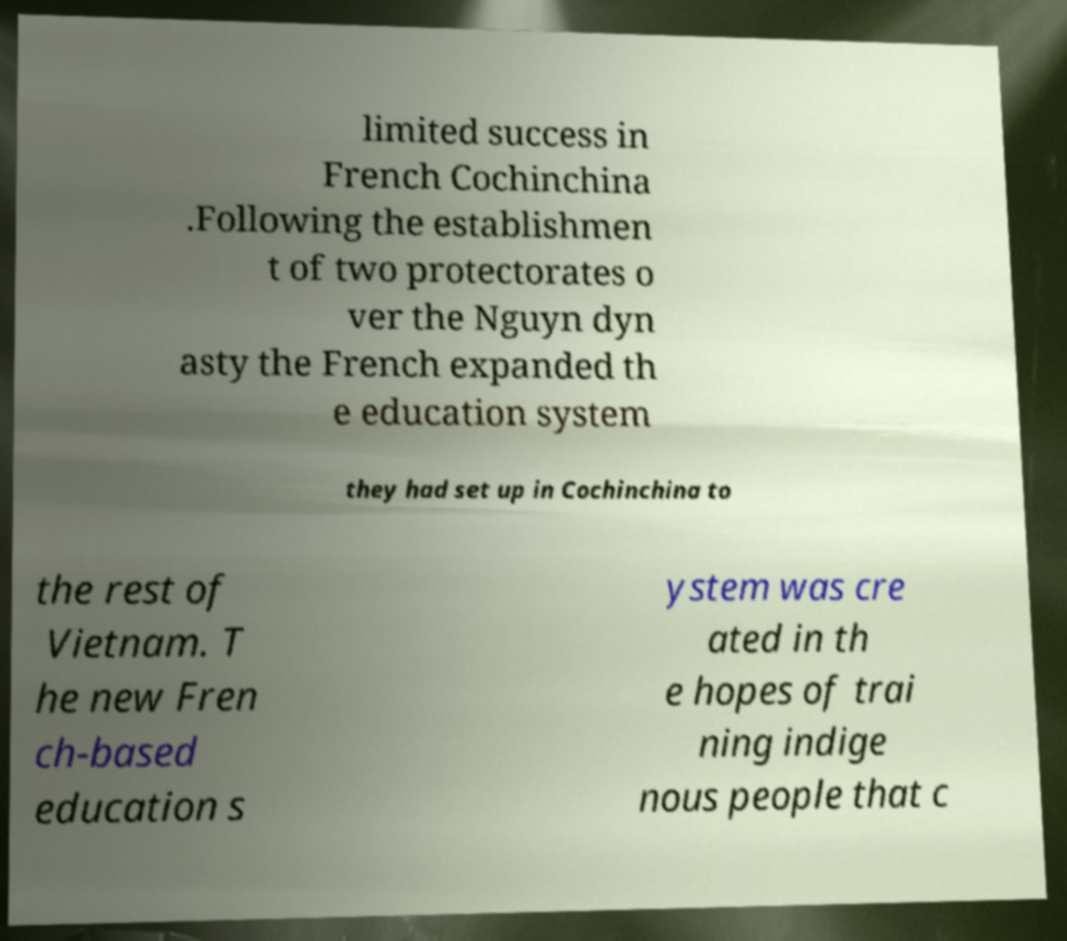Could you assist in decoding the text presented in this image and type it out clearly? limited success in French Cochinchina .Following the establishmen t of two protectorates o ver the Nguyn dyn asty the French expanded th e education system they had set up in Cochinchina to the rest of Vietnam. T he new Fren ch-based education s ystem was cre ated in th e hopes of trai ning indige nous people that c 